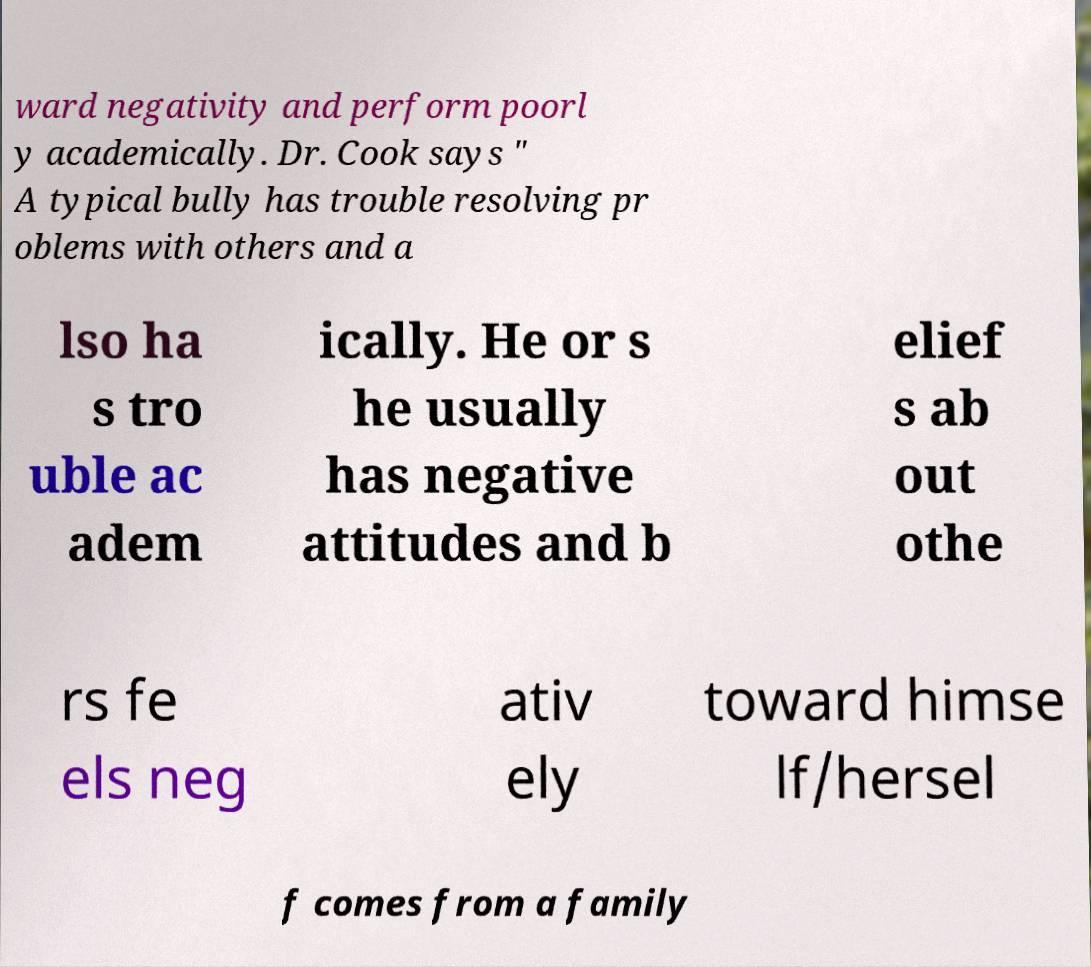Can you read and provide the text displayed in the image?This photo seems to have some interesting text. Can you extract and type it out for me? ward negativity and perform poorl y academically. Dr. Cook says " A typical bully has trouble resolving pr oblems with others and a lso ha s tro uble ac adem ically. He or s he usually has negative attitudes and b elief s ab out othe rs fe els neg ativ ely toward himse lf/hersel f comes from a family 